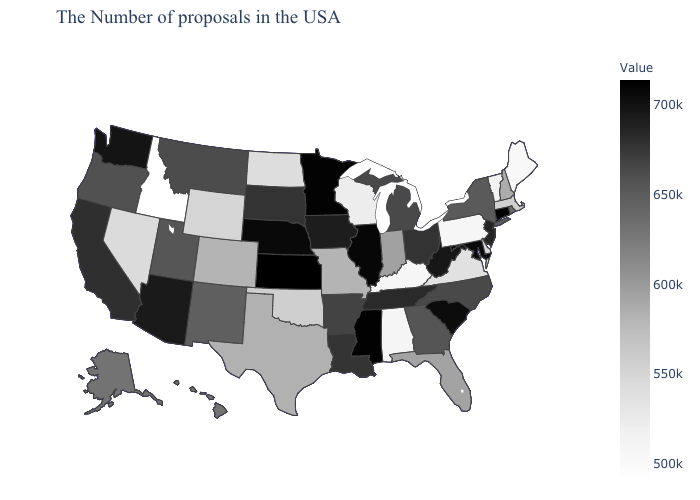Which states have the lowest value in the USA?
Give a very brief answer. Idaho. Does Wyoming have a higher value than Pennsylvania?
Keep it brief. Yes. Among the states that border Georgia , does Florida have the lowest value?
Quick response, please. No. Among the states that border Wyoming , which have the highest value?
Quick response, please. Nebraska. Which states have the lowest value in the West?
Answer briefly. Idaho. Does Idaho have the lowest value in the USA?
Concise answer only. Yes. Among the states that border Florida , which have the lowest value?
Concise answer only. Alabama. Does Oklahoma have a lower value than Tennessee?
Give a very brief answer. Yes. 